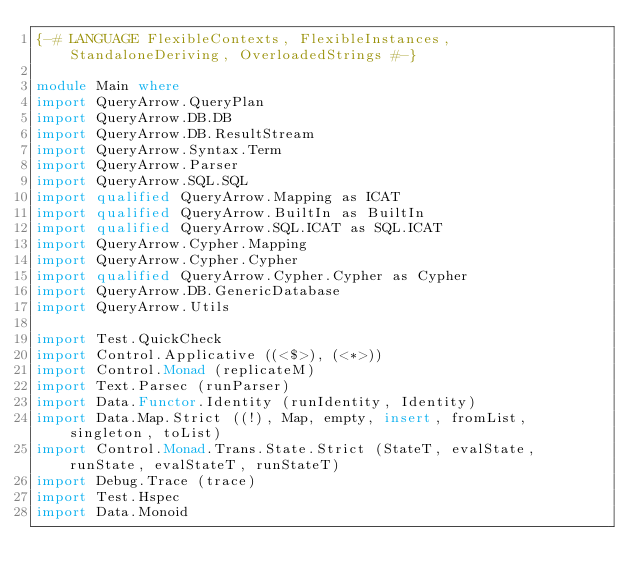Convert code to text. <code><loc_0><loc_0><loc_500><loc_500><_Haskell_>{-# LANGUAGE FlexibleContexts, FlexibleInstances, StandaloneDeriving, OverloadedStrings #-}

module Main where
import QueryArrow.QueryPlan
import QueryArrow.DB.DB
import QueryArrow.DB.ResultStream
import QueryArrow.Syntax.Term
import QueryArrow.Parser
import QueryArrow.SQL.SQL
import qualified QueryArrow.Mapping as ICAT
import qualified QueryArrow.BuiltIn as BuiltIn
import qualified QueryArrow.SQL.ICAT as SQL.ICAT
import QueryArrow.Cypher.Mapping
import QueryArrow.Cypher.Cypher
import qualified QueryArrow.Cypher.Cypher as Cypher
import QueryArrow.DB.GenericDatabase
import QueryArrow.Utils

import Test.QuickCheck
import Control.Applicative ((<$>), (<*>))
import Control.Monad (replicateM)
import Text.Parsec (runParser)
import Data.Functor.Identity (runIdentity, Identity)
import Data.Map.Strict ((!), Map, empty, insert, fromList, singleton, toList)
import Control.Monad.Trans.State.Strict (StateT, evalState, runState, evalStateT, runStateT)
import Debug.Trace (trace)
import Test.Hspec
import Data.Monoid</code> 